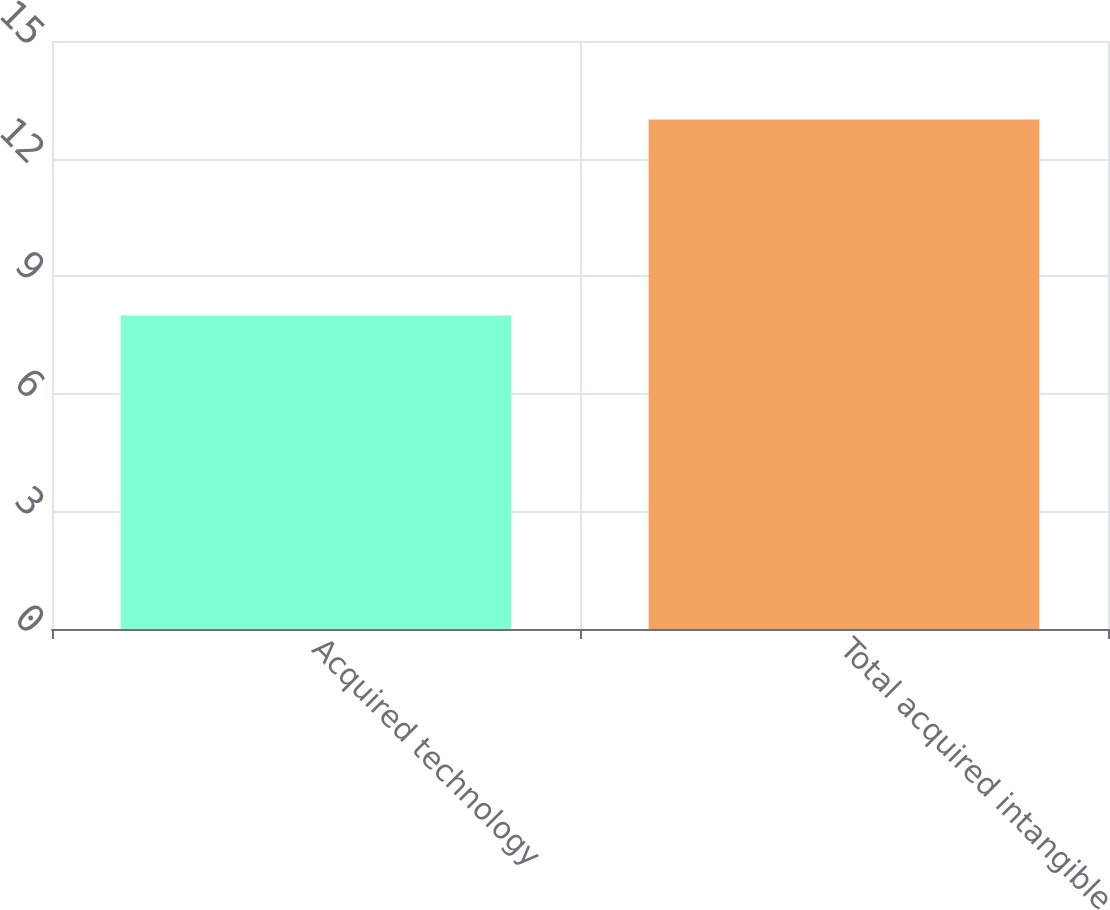Convert chart. <chart><loc_0><loc_0><loc_500><loc_500><bar_chart><fcel>Acquired technology<fcel>Total acquired intangible<nl><fcel>8<fcel>13<nl></chart> 